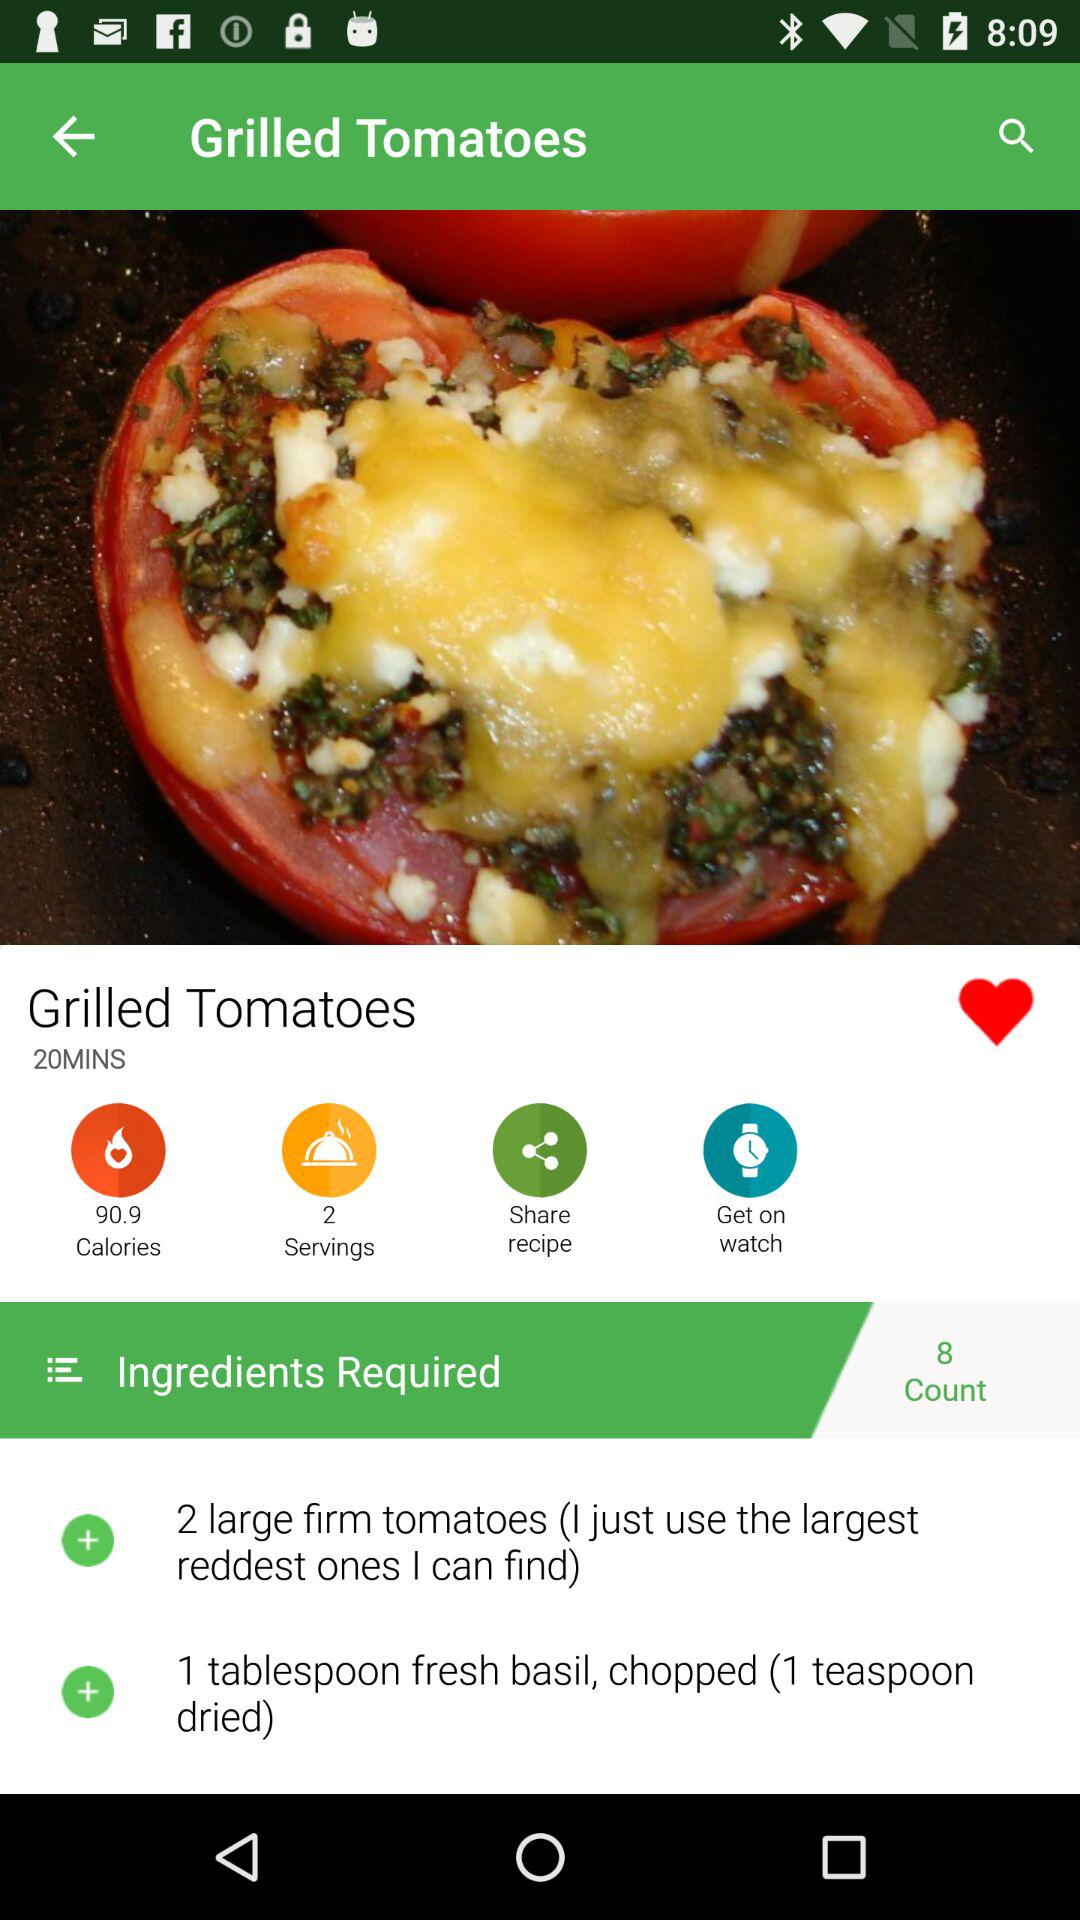How many tomatoes do you need to cook "Grilled Tomatoes"? You need 2 tomatoes to cook "Grilled Tomatoes". 